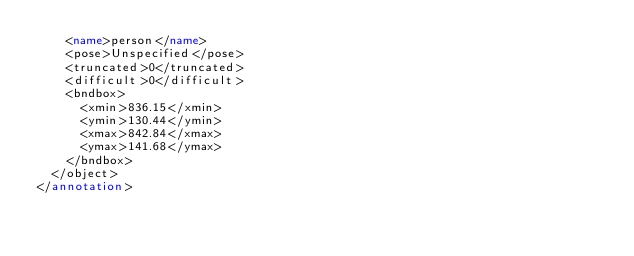<code> <loc_0><loc_0><loc_500><loc_500><_XML_>		<name>person</name>
		<pose>Unspecified</pose>
		<truncated>0</truncated>
		<difficult>0</difficult>
		<bndbox>
			<xmin>836.15</xmin>
			<ymin>130.44</ymin>
			<xmax>842.84</xmax>
			<ymax>141.68</ymax>
		</bndbox>
	</object>
</annotation>
</code> 